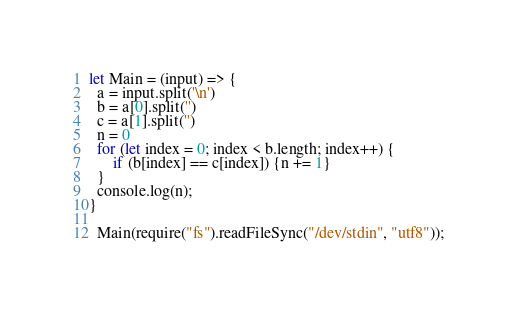Convert code to text. <code><loc_0><loc_0><loc_500><loc_500><_JavaScript_>let Main = (input) => {
  a = input.split('\n')
  b = a[0].split('')
  c = a[1].split('')
  n = 0
  for (let index = 0; index < b.length; index++) {
      if (b[index] == c[index]) {n += 1} 
  }
  console.log(n);
}
 
  Main(require("fs").readFileSync("/dev/stdin", "utf8"));</code> 